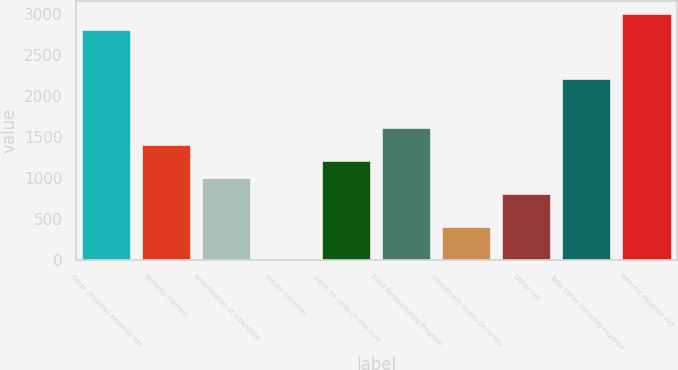Convert chart. <chart><loc_0><loc_0><loc_500><loc_500><bar_chart><fcel>Other (income) expense net<fcel>Minority interest<fcel>Amortization of intangible<fcel>Equity (income)<fcel>Gains on sales of non-core<fcel>2004 Restructuring Program<fcel>Investment losses (income)<fcel>Other net<fcel>Total Other (income) expense<fcel>Interest expense net<nl><fcel>2807.04<fcel>1405.22<fcel>1004.7<fcel>3.4<fcel>1204.96<fcel>1605.48<fcel>403.92<fcel>804.44<fcel>2206.26<fcel>3007.3<nl></chart> 